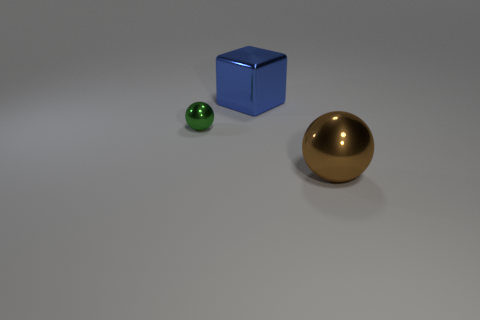Add 3 yellow rubber cylinders. How many objects exist? 6 Subtract all spheres. How many objects are left? 1 Subtract 0 red cylinders. How many objects are left? 3 Subtract all shiny blocks. Subtract all spheres. How many objects are left? 0 Add 1 green balls. How many green balls are left? 2 Add 1 tiny green things. How many tiny green things exist? 2 